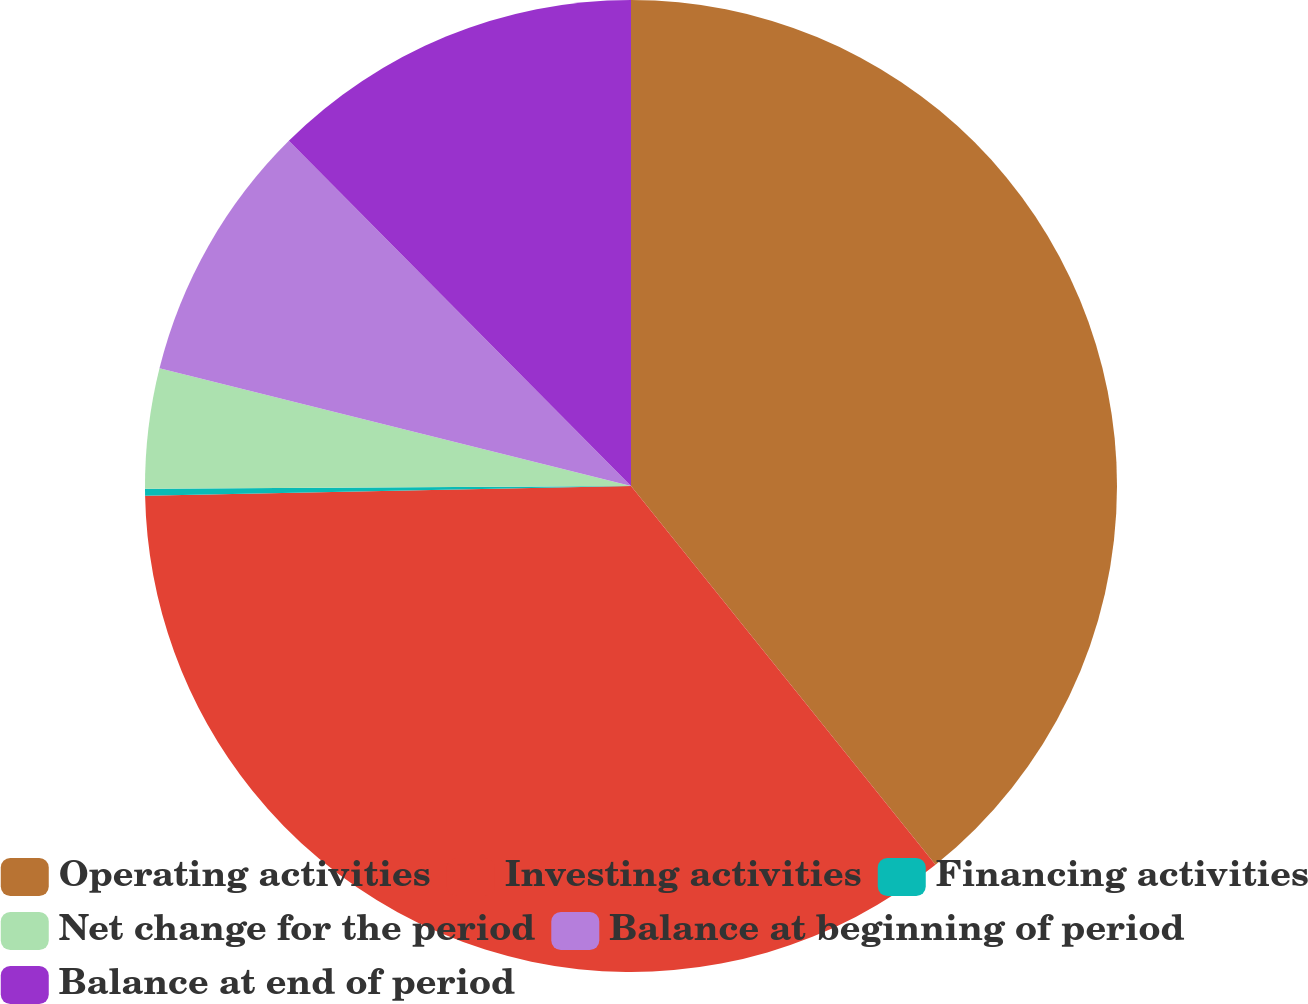Convert chart. <chart><loc_0><loc_0><loc_500><loc_500><pie_chart><fcel>Operating activities<fcel>Investing activities<fcel>Financing activities<fcel>Net change for the period<fcel>Balance at beginning of period<fcel>Balance at end of period<nl><fcel>39.22%<fcel>35.45%<fcel>0.23%<fcel>3.99%<fcel>8.67%<fcel>12.43%<nl></chart> 